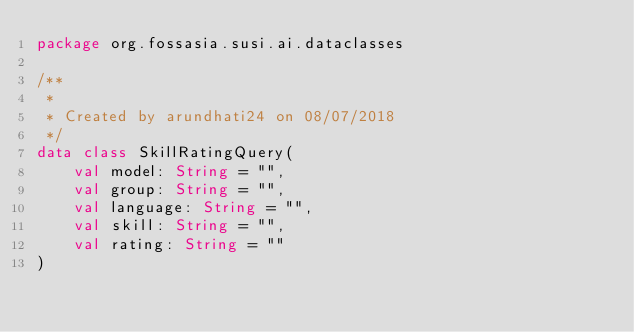Convert code to text. <code><loc_0><loc_0><loc_500><loc_500><_Kotlin_>package org.fossasia.susi.ai.dataclasses

/**
 *
 * Created by arundhati24 on 08/07/2018
 */
data class SkillRatingQuery(
    val model: String = "",
    val group: String = "",
    val language: String = "",
    val skill: String = "",
    val rating: String = ""
)
</code> 